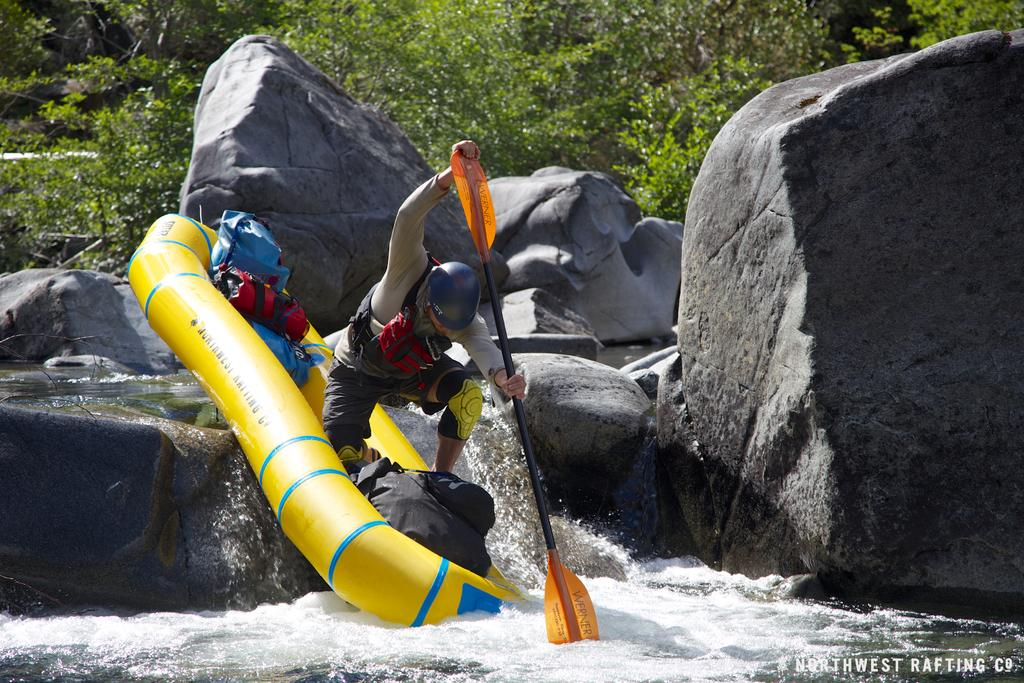Who is in the image? There is a person in the image. What is the person holding? The person is holding a paddle. What activity is the person engaged in? The person is rafting on the water. What else can be seen on the inflatable raft? There are bags on the inflatable raft. What can be seen in the background of the image? There are stones and trees in the background of the image. What type of music can be heard playing in the background of the image? There is no music present in the image; it is a person rafting on the water with a paddle and bags on an inflatable raft. 